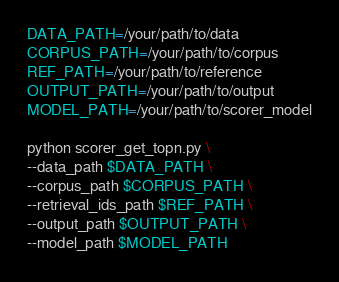Convert code to text. <code><loc_0><loc_0><loc_500><loc_500><_Bash_>DATA_PATH=/your/path/to/data
CORPUS_PATH=/your/path/to/corpus
REF_PATH=/your/path/to/reference
OUTPUT_PATH=/your/path/to/output
MODEL_PATH=/your/path/to/scorer_model

python scorer_get_topn.py \
--data_path $DATA_PATH \
--corpus_path $CORPUS_PATH \
--retrieval_ids_path $REF_PATH \
--output_path $OUTPUT_PATH \
--model_path $MODEL_PATH</code> 